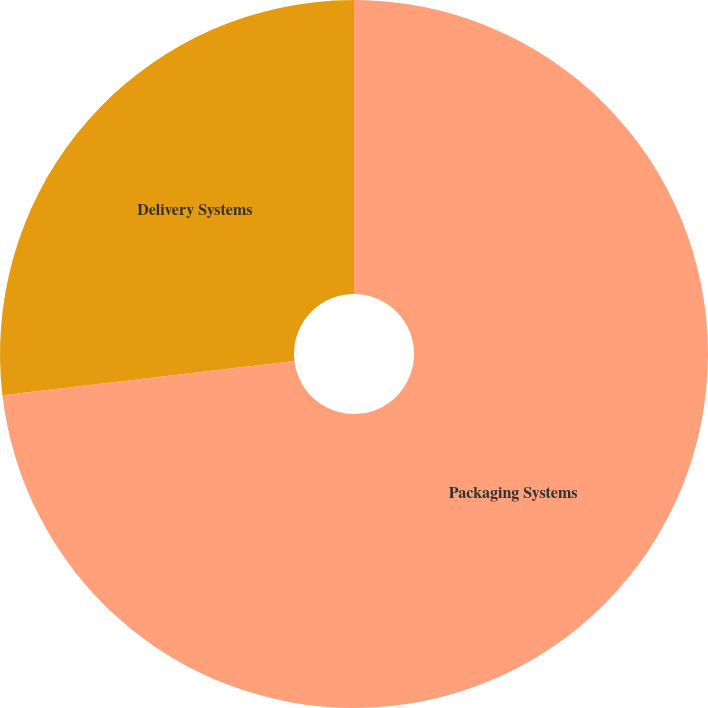Convert chart. <chart><loc_0><loc_0><loc_500><loc_500><pie_chart><fcel>Packaging Systems<fcel>Delivery Systems<nl><fcel>73.14%<fcel>26.86%<nl></chart> 